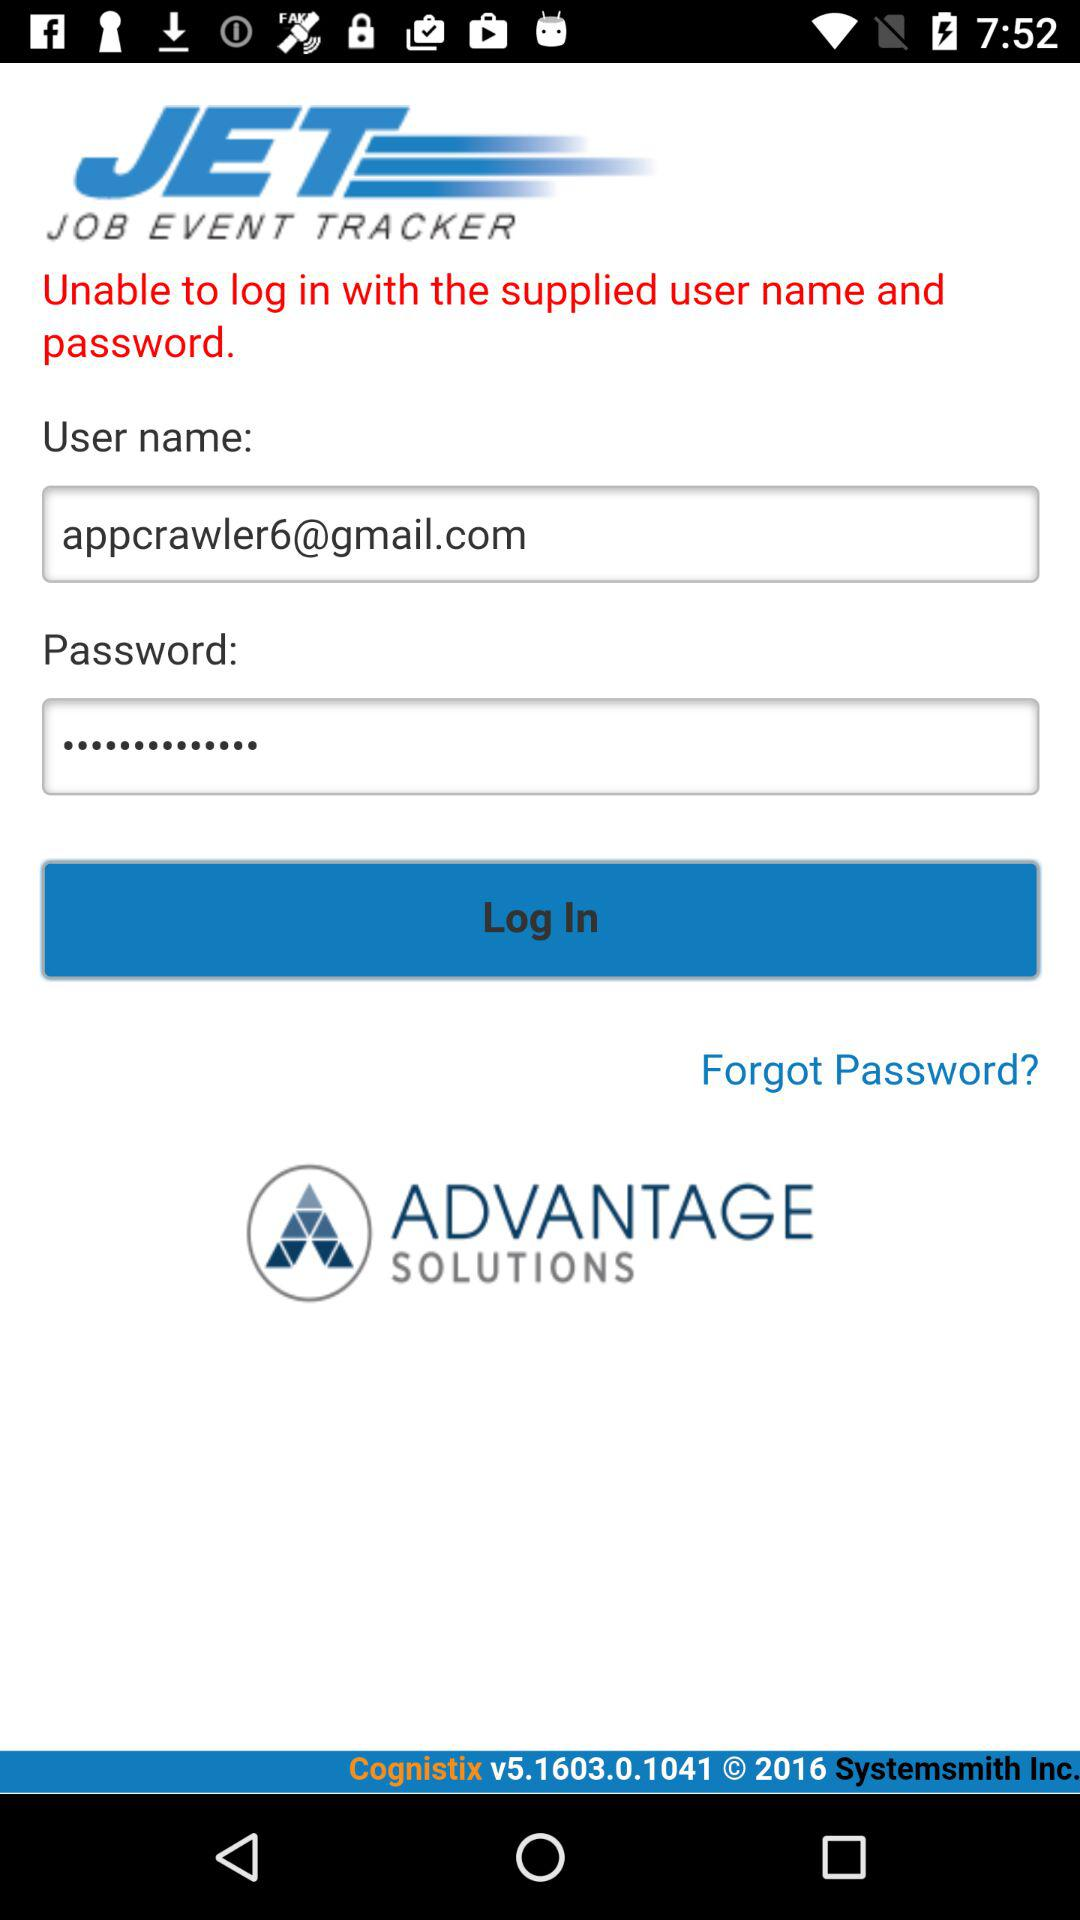How many text inputs contain an email address?
Answer the question using a single word or phrase. 1 